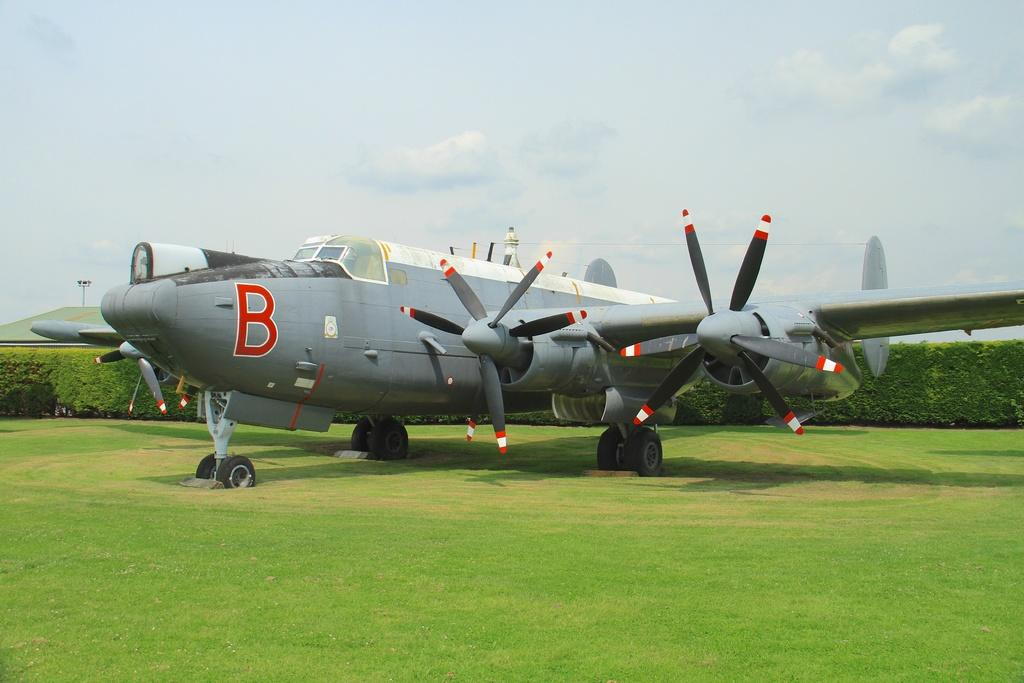What is the main subject in the center of the image? There is an aeroplane in the center of the image. What can be seen in the background of the image? There is a hedge and a pole in the background of the image. What is visible at the top of the image? The sky is visible at the top of the image. Where is the garden located in the image? There is no garden present in the image. What type of ray is visible in the image? There is no ray present in the image. 